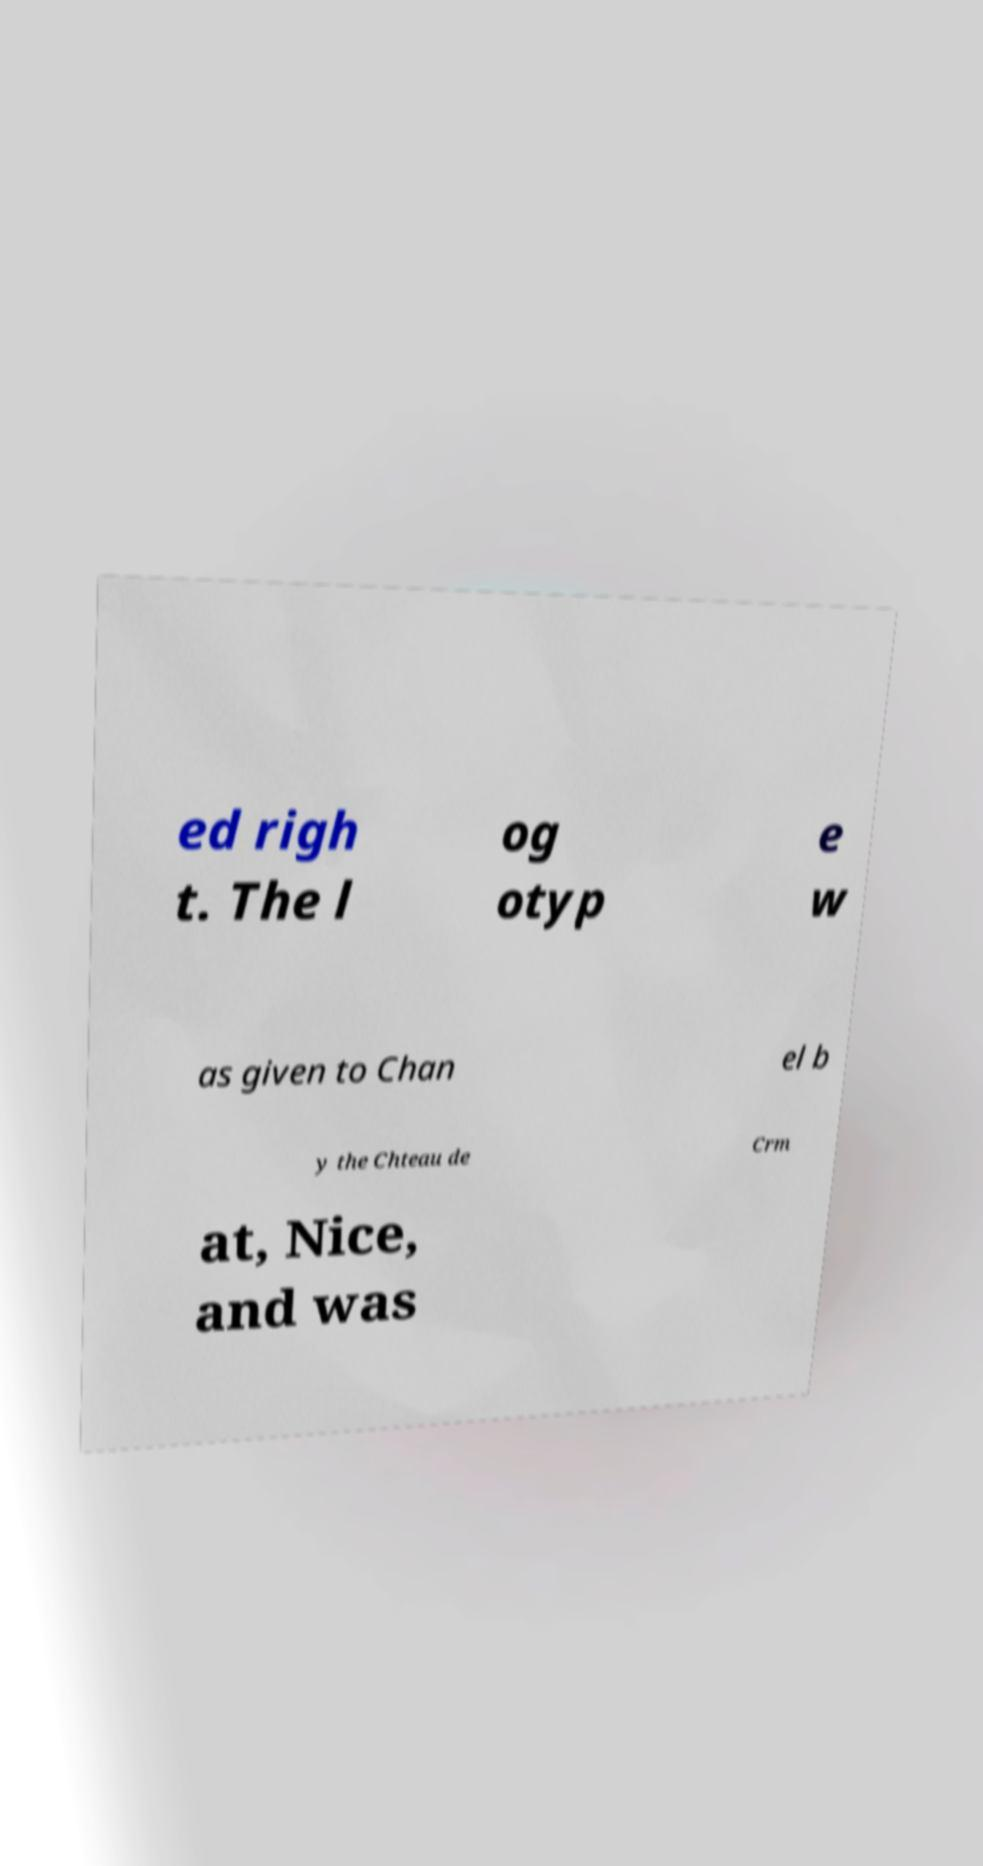Could you assist in decoding the text presented in this image and type it out clearly? ed righ t. The l og otyp e w as given to Chan el b y the Chteau de Crm at, Nice, and was 